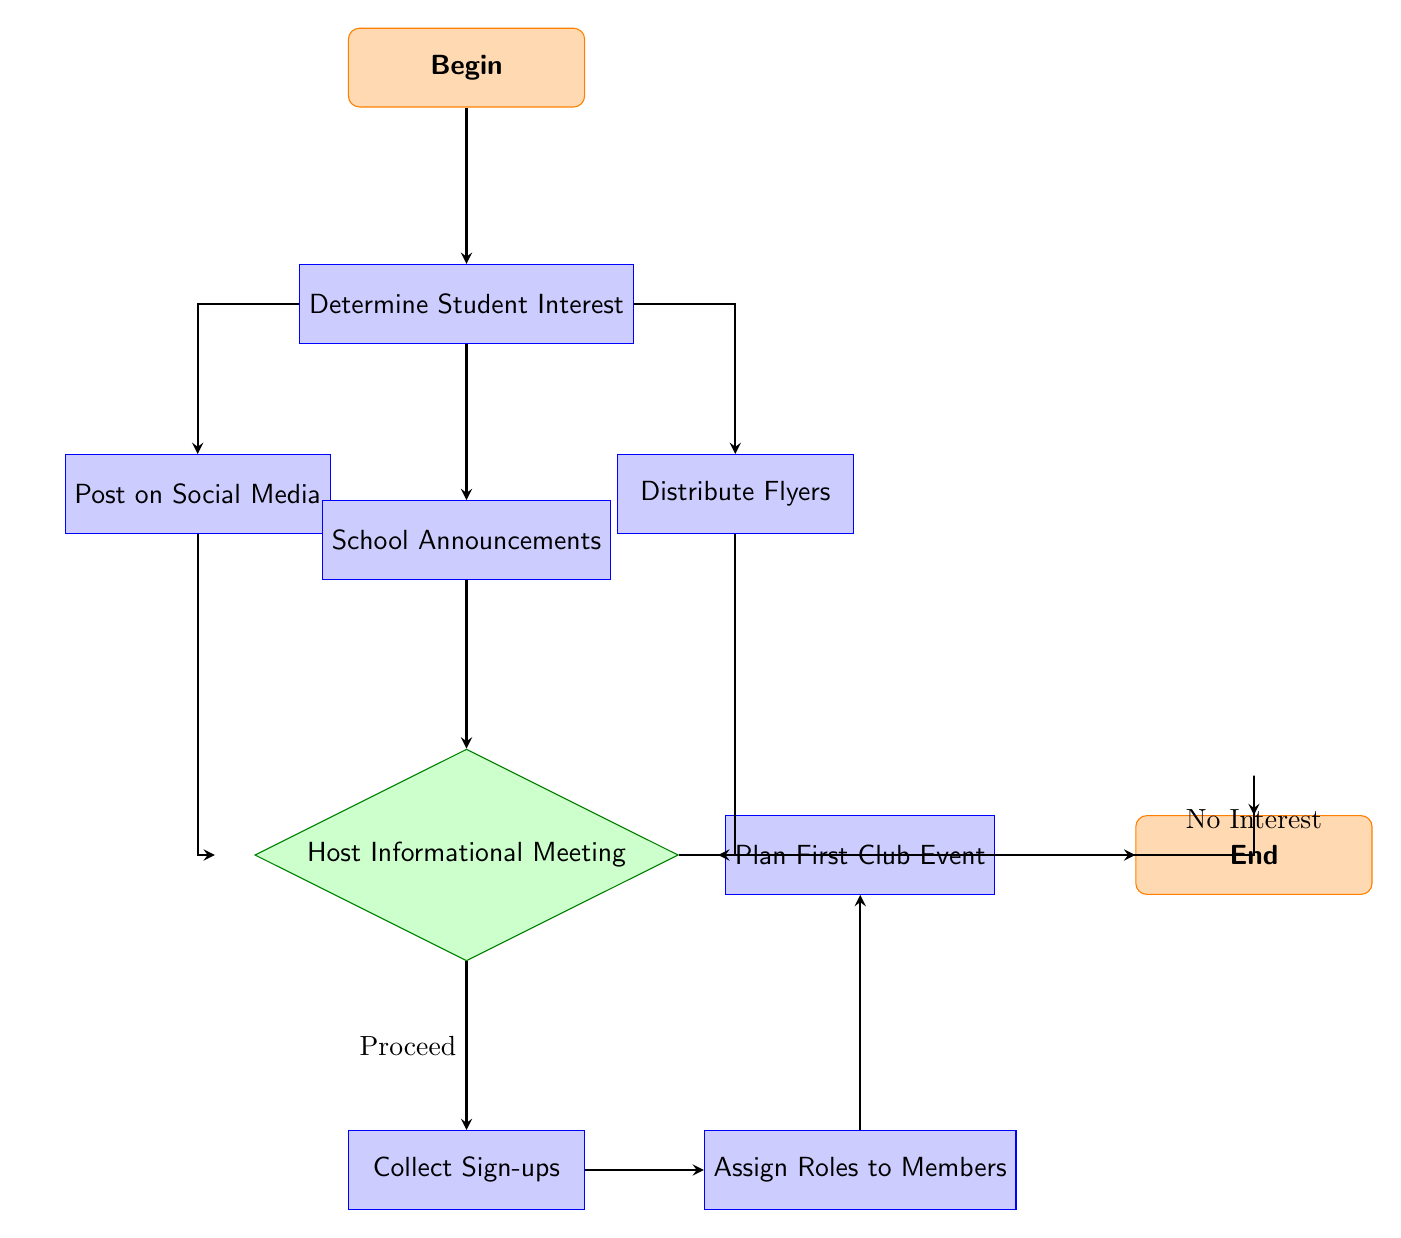What is the first action in the flowchart? The flowchart begins with the "Begin" node, which leads to the first action node "Determine Student Interest."
Answer: Determine Student Interest How many action nodes are in the diagram? The diagram contains four action nodes: "Post on Social Media," "School Announcements," "Distribute Flyers," and "Collect Sign-ups" (total = 4).
Answer: 4 What happens if there is no interest after the informational meeting? If there is "No Interest" after the informational meeting, the flowchart branches directly to the "End" node, terminating further actions.
Answer: End Which node comes after "Host Informational Meeting" if there is a positive response? Following a positive response, or "Proceed," from the "Host Informational Meeting," the next action taken is "Collect Sign-ups."
Answer: Collect Sign-ups What are the three methods for determining student interest in the club? The three methods listed in the flowchart are "Post on Social Media," "School Announcements," and "Distribute Flyers."
Answer: Post on Social Media, School Announcements, Distribute Flyers What is the final action that occurs before the flowchart ends? The final action before reaching the "End" node is "Plan First Club Event." The flowchart shows that after assigning roles, this event is planned next.
Answer: Plan First Club Event If "Collect Sign-ups" is completed, what is the next step? After "Collect Sign-ups," the flowchart indicates that the next step is to "Assign Roles to Members."
Answer: Assign Roles to Members How does the flowchart represent the decision-making process? The decision-making process occurs at the "Host Informational Meeting" node, which leads to two options: "Proceed" and "No Interest."
Answer: Host Informational Meeting Which actions follow the initial step of determining interest? After "Determine Student Interest," the subsequent actions are "Post on Social Media," "School Announcements," and "Distribute Flyers."
Answer: Post on Social Media, School Announcements, Distribute Flyers 